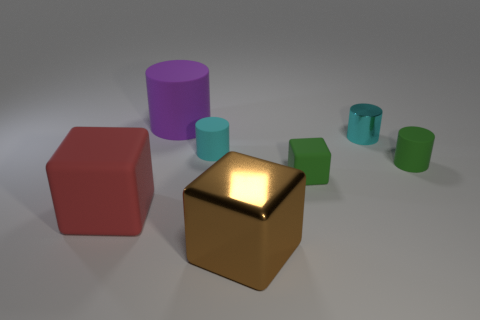What time of day might it be in this scene? Given the neutral background and the soft shadows cast by the objects, it's hard to determine the exact time of day from the image alone. The lighting seems artificial, implying an indoor setting where time of day is less relevant. 